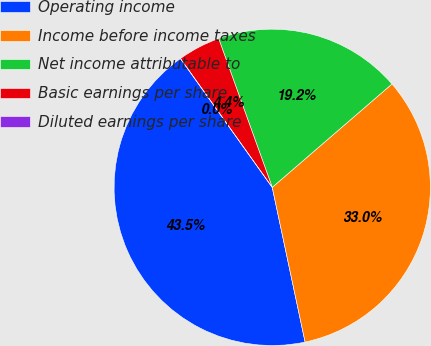<chart> <loc_0><loc_0><loc_500><loc_500><pie_chart><fcel>Operating income<fcel>Income before income taxes<fcel>Net income attributable to<fcel>Basic earnings per share<fcel>Diluted earnings per share<nl><fcel>43.48%<fcel>33.0%<fcel>19.17%<fcel>4.35%<fcel>0.0%<nl></chart> 